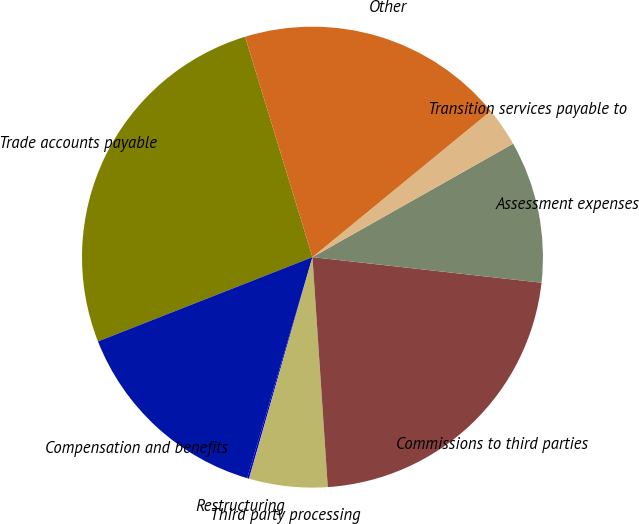Convert chart. <chart><loc_0><loc_0><loc_500><loc_500><pie_chart><fcel>Trade accounts payable<fcel>Compensation and benefits<fcel>Restructuring<fcel>Third party processing<fcel>Commissions to third parties<fcel>Assessment expenses<fcel>Transition services payable to<fcel>Other<nl><fcel>26.24%<fcel>14.47%<fcel>0.13%<fcel>5.5%<fcel>22.17%<fcel>9.96%<fcel>2.74%<fcel>18.79%<nl></chart> 